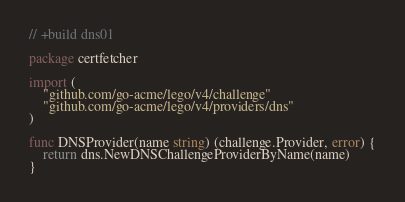Convert code to text. <code><loc_0><loc_0><loc_500><loc_500><_Go_>// +build dns01

package certfetcher

import (
	"github.com/go-acme/lego/v4/challenge"
	"github.com/go-acme/lego/v4/providers/dns"
)

func DNSProvider(name string) (challenge.Provider, error) {
	return dns.NewDNSChallengeProviderByName(name)
}
</code> 